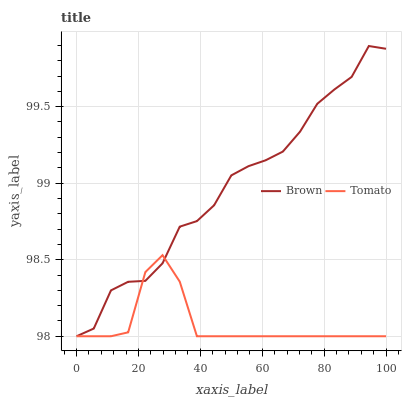Does Tomato have the minimum area under the curve?
Answer yes or no. Yes. Does Brown have the maximum area under the curve?
Answer yes or no. Yes. Does Brown have the minimum area under the curve?
Answer yes or no. No. Is Tomato the smoothest?
Answer yes or no. Yes. Is Brown the roughest?
Answer yes or no. Yes. Is Brown the smoothest?
Answer yes or no. No. Does Tomato have the lowest value?
Answer yes or no. Yes. Does Brown have the highest value?
Answer yes or no. Yes. Does Tomato intersect Brown?
Answer yes or no. Yes. Is Tomato less than Brown?
Answer yes or no. No. Is Tomato greater than Brown?
Answer yes or no. No. 